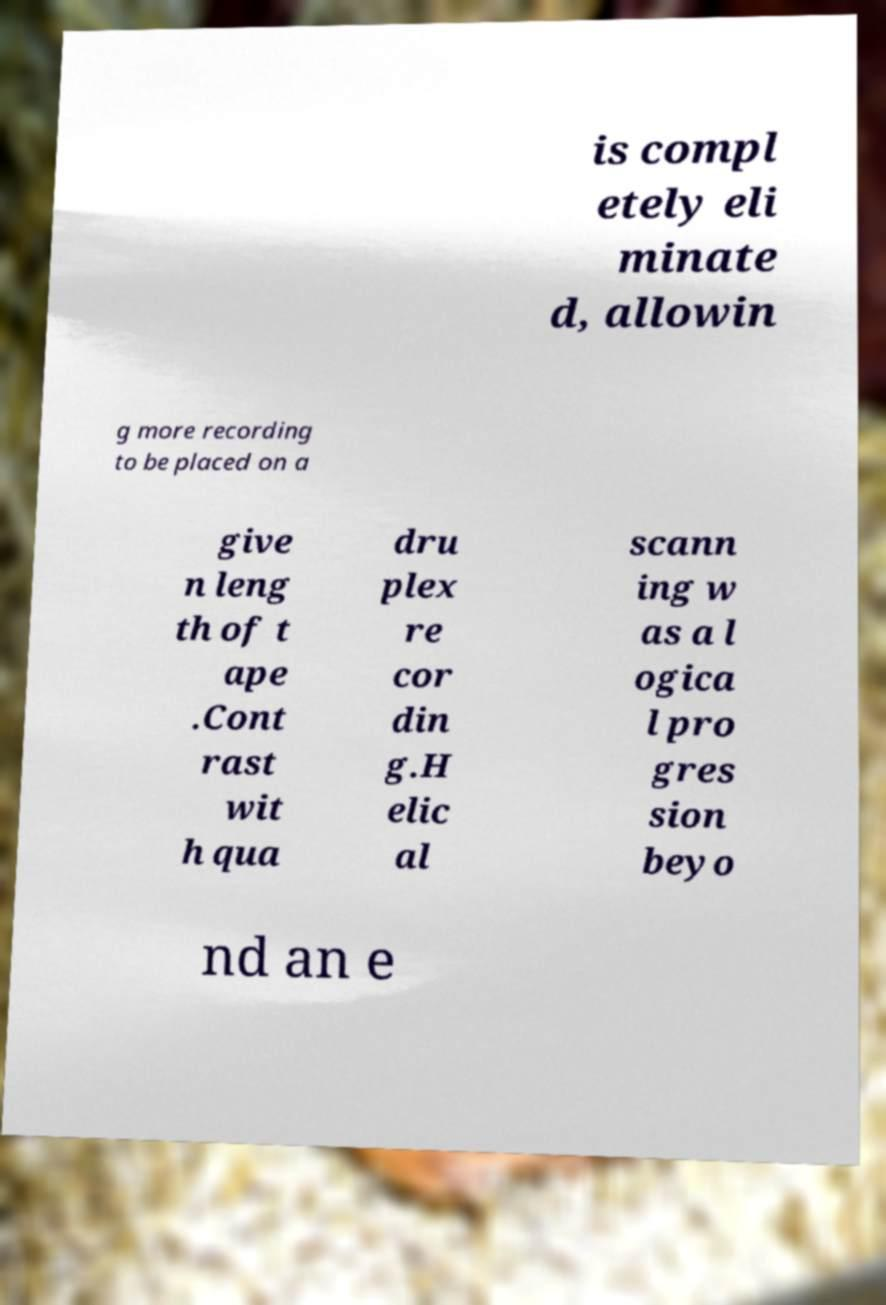What messages or text are displayed in this image? I need them in a readable, typed format. is compl etely eli minate d, allowin g more recording to be placed on a give n leng th of t ape .Cont rast wit h qua dru plex re cor din g.H elic al scann ing w as a l ogica l pro gres sion beyo nd an e 